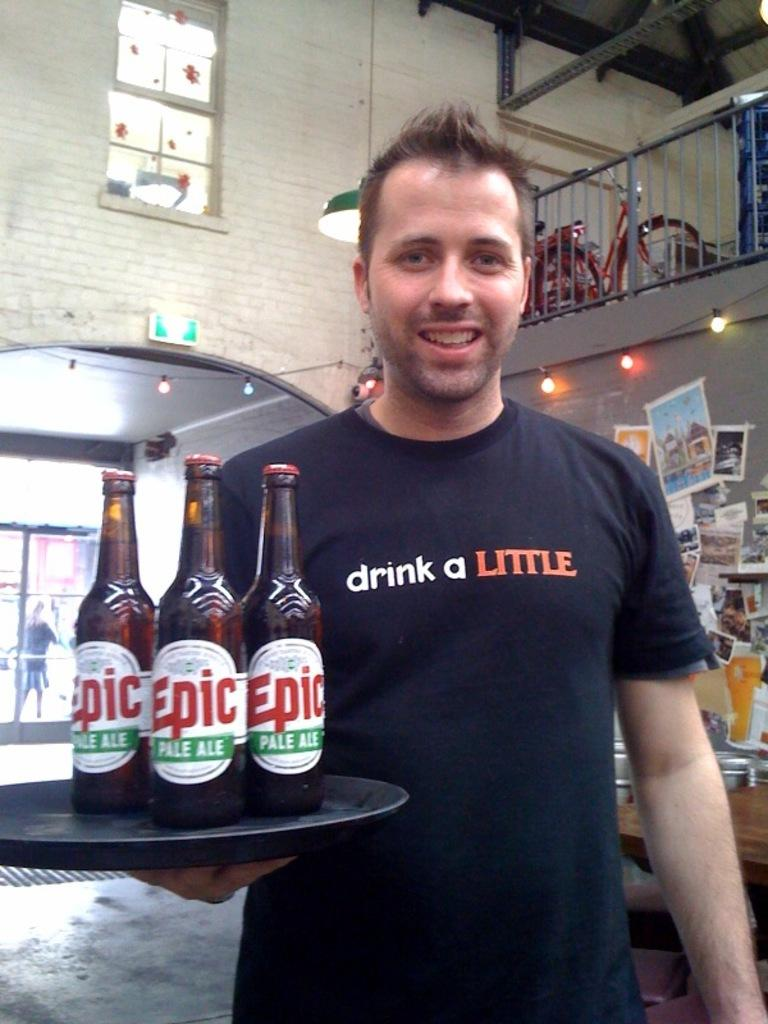<image>
Relay a brief, clear account of the picture shown. A man carries bottles of Epic beer on a tray. 